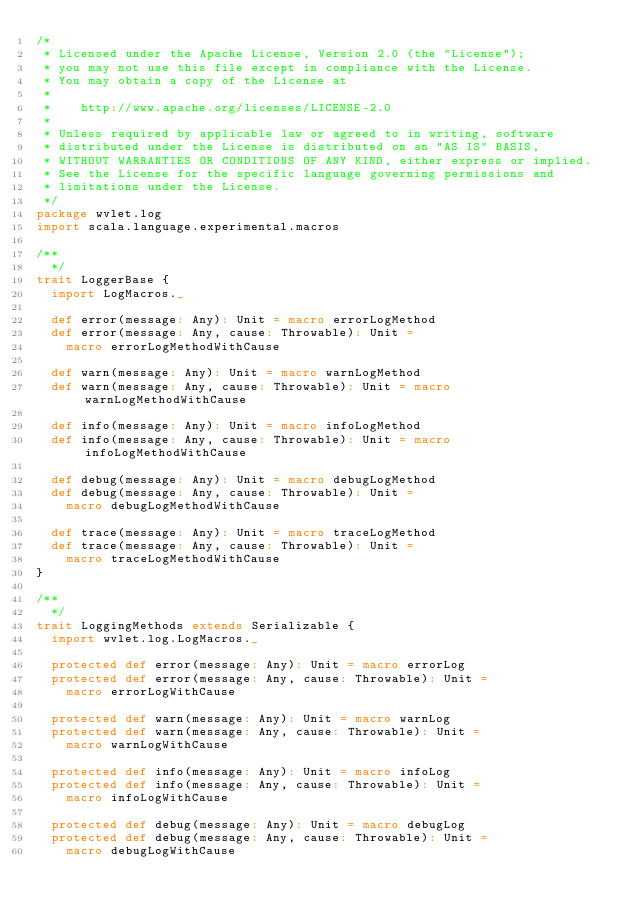Convert code to text. <code><loc_0><loc_0><loc_500><loc_500><_Scala_>/*
 * Licensed under the Apache License, Version 2.0 (the "License");
 * you may not use this file except in compliance with the License.
 * You may obtain a copy of the License at
 *
 *    http://www.apache.org/licenses/LICENSE-2.0
 *
 * Unless required by applicable law or agreed to in writing, software
 * distributed under the License is distributed on an "AS IS" BASIS,
 * WITHOUT WARRANTIES OR CONDITIONS OF ANY KIND, either express or implied.
 * See the License for the specific language governing permissions and
 * limitations under the License.
 */
package wvlet.log
import scala.language.experimental.macros

/**
  */
trait LoggerBase {
  import LogMacros._

  def error(message: Any): Unit = macro errorLogMethod
  def error(message: Any, cause: Throwable): Unit =
    macro errorLogMethodWithCause

  def warn(message: Any): Unit = macro warnLogMethod
  def warn(message: Any, cause: Throwable): Unit = macro warnLogMethodWithCause

  def info(message: Any): Unit = macro infoLogMethod
  def info(message: Any, cause: Throwable): Unit = macro infoLogMethodWithCause

  def debug(message: Any): Unit = macro debugLogMethod
  def debug(message: Any, cause: Throwable): Unit =
    macro debugLogMethodWithCause

  def trace(message: Any): Unit = macro traceLogMethod
  def trace(message: Any, cause: Throwable): Unit =
    macro traceLogMethodWithCause
}

/**
  */
trait LoggingMethods extends Serializable {
  import wvlet.log.LogMacros._

  protected def error(message: Any): Unit = macro errorLog
  protected def error(message: Any, cause: Throwable): Unit =
    macro errorLogWithCause

  protected def warn(message: Any): Unit = macro warnLog
  protected def warn(message: Any, cause: Throwable): Unit =
    macro warnLogWithCause

  protected def info(message: Any): Unit = macro infoLog
  protected def info(message: Any, cause: Throwable): Unit =
    macro infoLogWithCause

  protected def debug(message: Any): Unit = macro debugLog
  protected def debug(message: Any, cause: Throwable): Unit =
    macro debugLogWithCause
</code> 